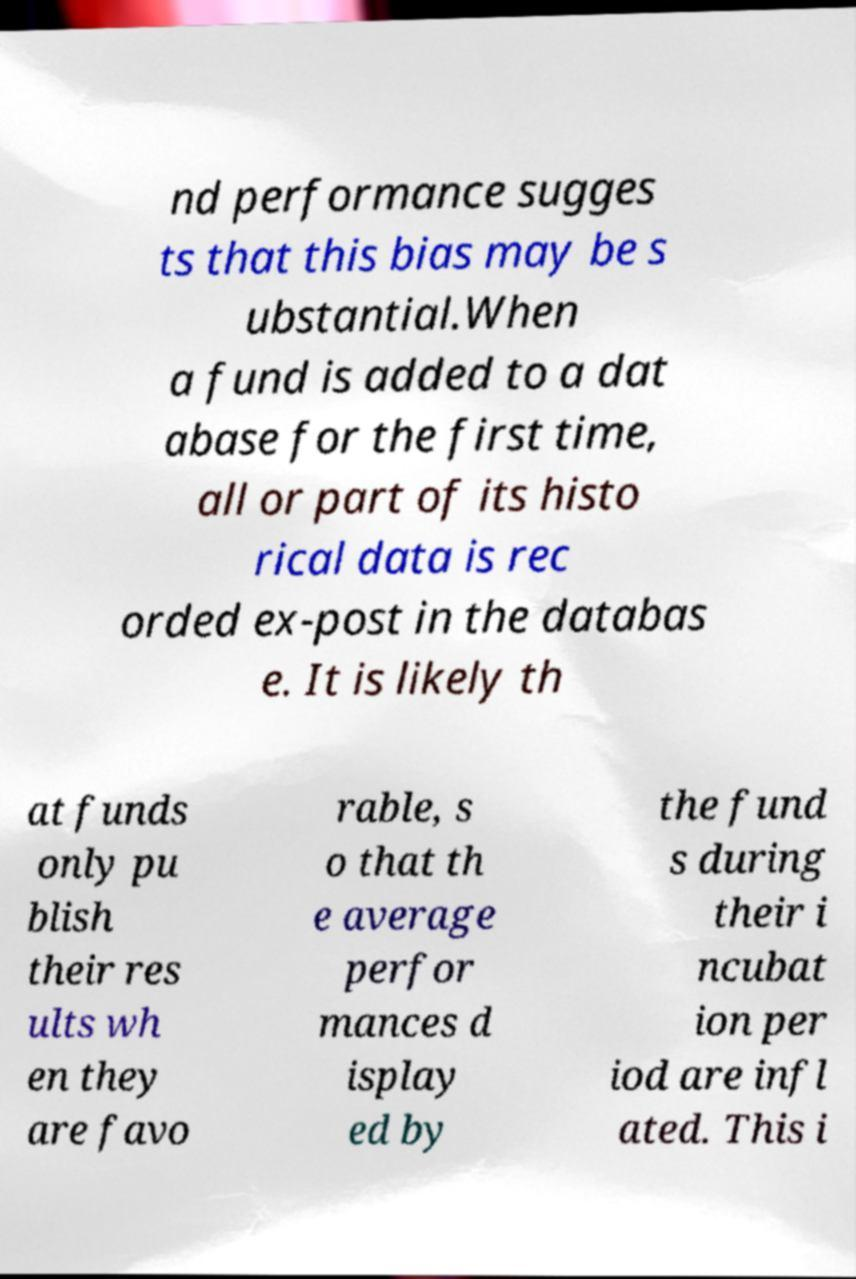Can you accurately transcribe the text from the provided image for me? nd performance sugges ts that this bias may be s ubstantial.When a fund is added to a dat abase for the first time, all or part of its histo rical data is rec orded ex-post in the databas e. It is likely th at funds only pu blish their res ults wh en they are favo rable, s o that th e average perfor mances d isplay ed by the fund s during their i ncubat ion per iod are infl ated. This i 